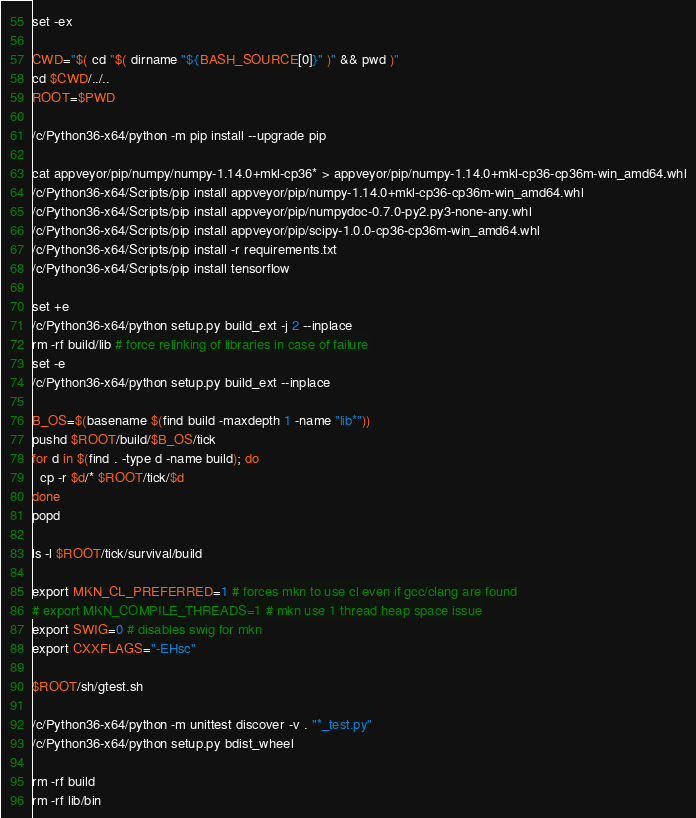Convert code to text. <code><loc_0><loc_0><loc_500><loc_500><_Bash_>set -ex

CWD="$( cd "$( dirname "${BASH_SOURCE[0]}" )" && pwd )"
cd $CWD/../..
ROOT=$PWD

/c/Python36-x64/python -m pip install --upgrade pip

cat appveyor/pip/numpy/numpy-1.14.0+mkl-cp36* > appveyor/pip/numpy-1.14.0+mkl-cp36-cp36m-win_amd64.whl
/c/Python36-x64/Scripts/pip install appveyor/pip/numpy-1.14.0+mkl-cp36-cp36m-win_amd64.whl
/c/Python36-x64/Scripts/pip install appveyor/pip/numpydoc-0.7.0-py2.py3-none-any.whl
/c/Python36-x64/Scripts/pip install appveyor/pip/scipy-1.0.0-cp36-cp36m-win_amd64.whl
/c/Python36-x64/Scripts/pip install -r requirements.txt
/c/Python36-x64/Scripts/pip install tensorflow

set +e
/c/Python36-x64/python setup.py build_ext -j 2 --inplace
rm -rf build/lib # force relinking of libraries in case of failure
set -e
/c/Python36-x64/python setup.py build_ext --inplace

B_OS=$(basename $(find build -maxdepth 1 -name "lib*"))
pushd $ROOT/build/$B_OS/tick
for d in $(find . -type d -name build); do
  cp -r $d/* $ROOT/tick/$d
done
popd

ls -l $ROOT/tick/survival/build

export MKN_CL_PREFERRED=1 # forces mkn to use cl even if gcc/clang are found
# export MKN_COMPILE_THREADS=1 # mkn use 1 thread heap space issue
export SWIG=0 # disables swig for mkn
export CXXFLAGS="-EHsc"

$ROOT/sh/gtest.sh

/c/Python36-x64/python -m unittest discover -v . "*_test.py"
/c/Python36-x64/python setup.py bdist_wheel

rm -rf build
rm -rf lib/bin
</code> 